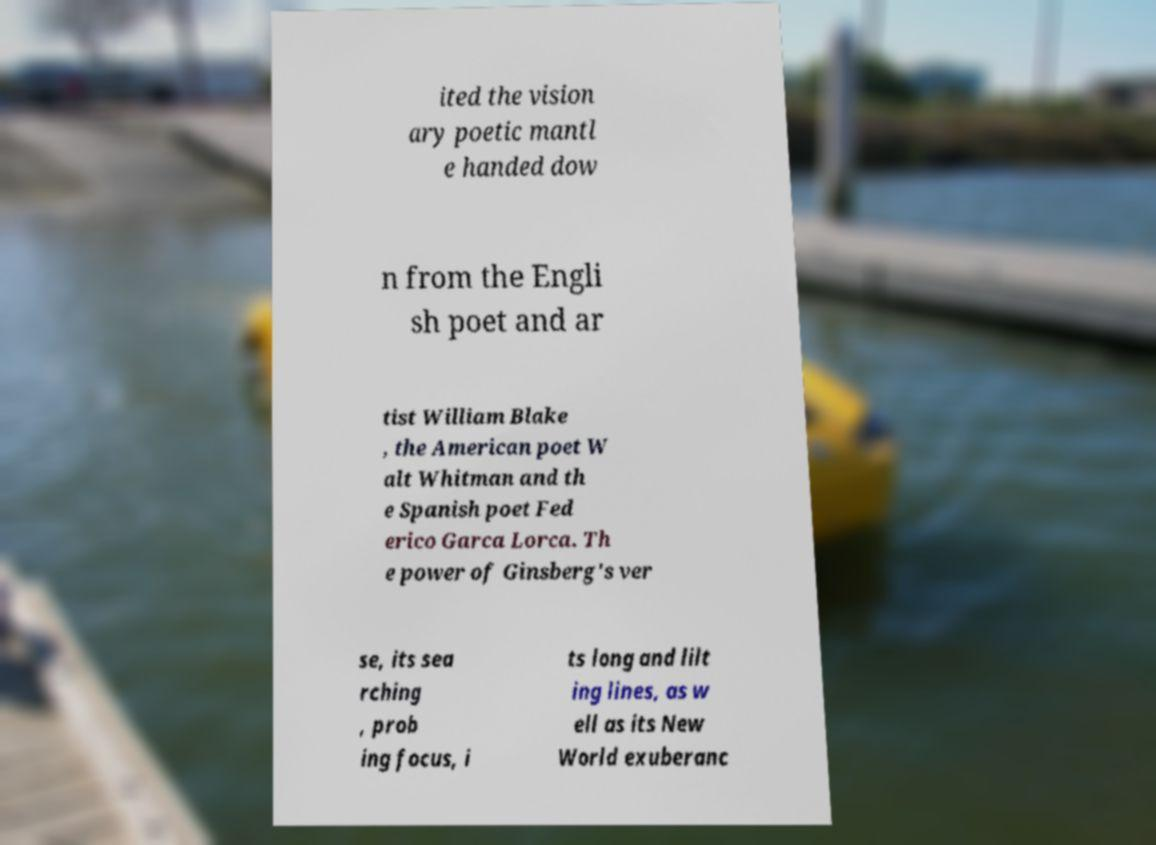Could you assist in decoding the text presented in this image and type it out clearly? ited the vision ary poetic mantl e handed dow n from the Engli sh poet and ar tist William Blake , the American poet W alt Whitman and th e Spanish poet Fed erico Garca Lorca. Th e power of Ginsberg's ver se, its sea rching , prob ing focus, i ts long and lilt ing lines, as w ell as its New World exuberanc 